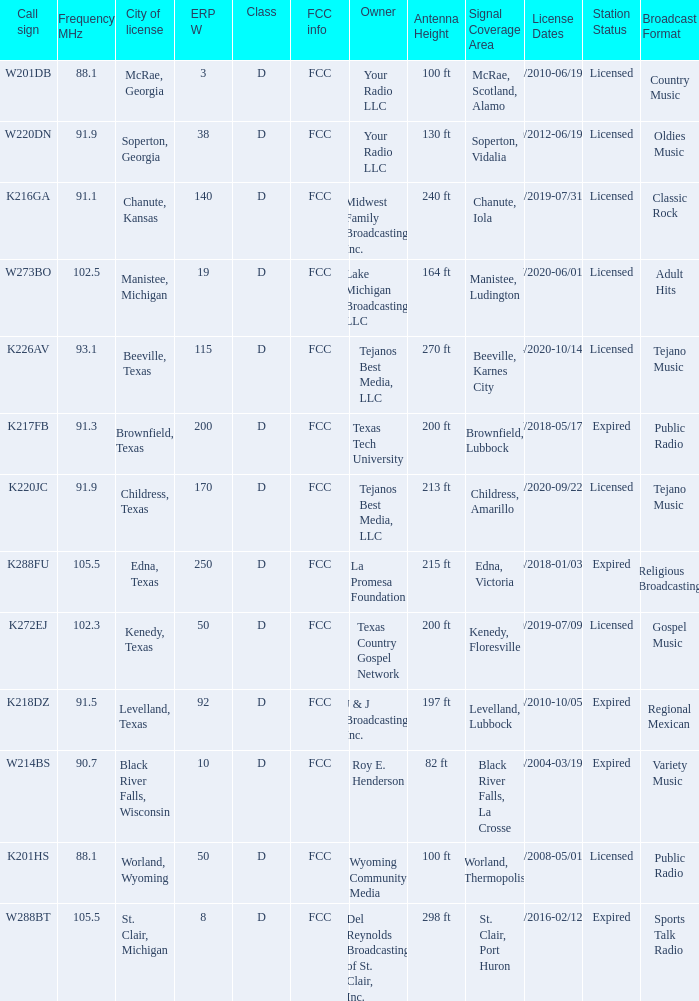What is Call Sign, when ERP W is greater than 50? K216GA, K226AV, K217FB, K220JC, K288FU, K218DZ. 